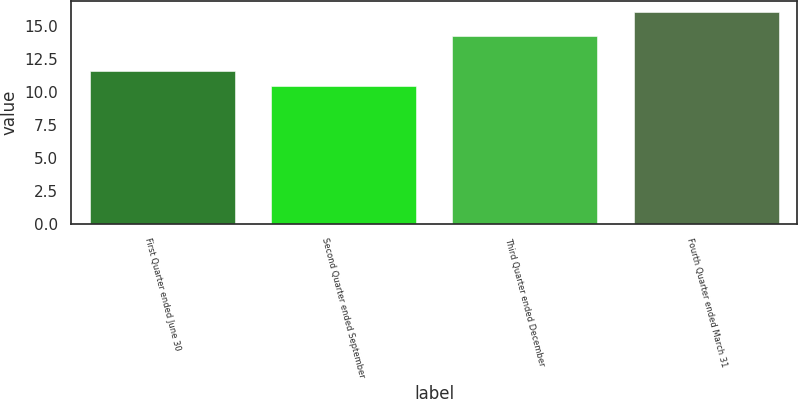<chart> <loc_0><loc_0><loc_500><loc_500><bar_chart><fcel>First Quarter ended June 30<fcel>Second Quarter ended September<fcel>Third Quarter ended December<fcel>Fourth Quarter ended March 31<nl><fcel>11.59<fcel>10.47<fcel>14.22<fcel>16.05<nl></chart> 